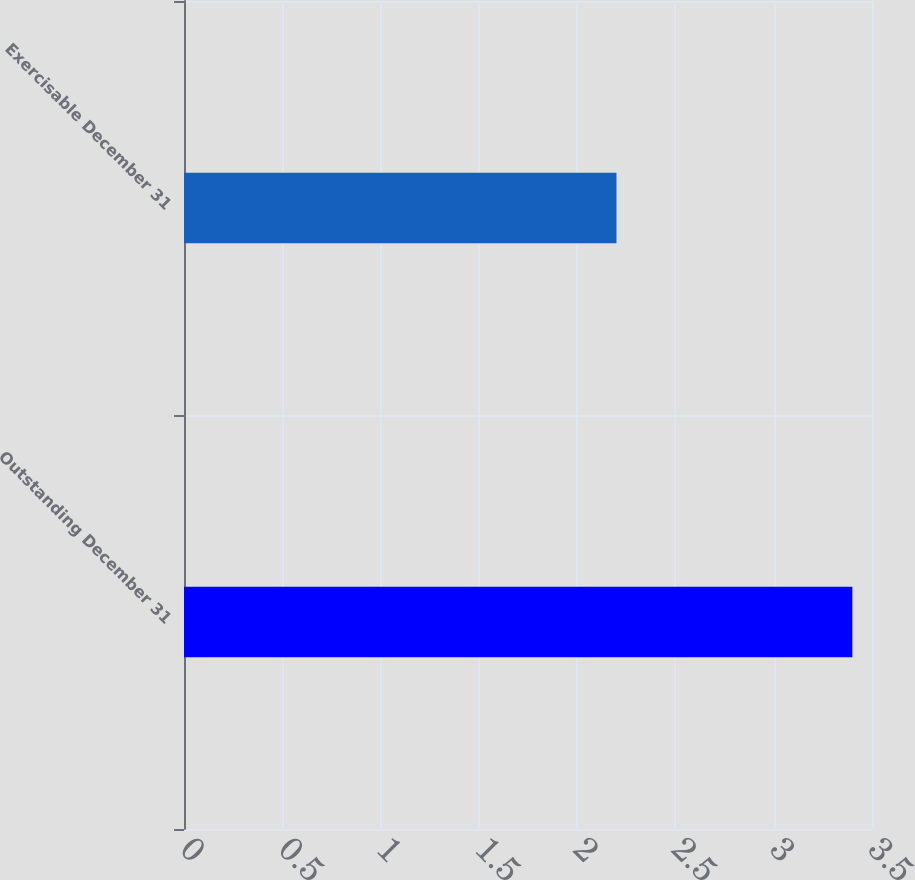<chart> <loc_0><loc_0><loc_500><loc_500><bar_chart><fcel>Outstanding December 31<fcel>Exercisable December 31<nl><fcel>3.4<fcel>2.2<nl></chart> 